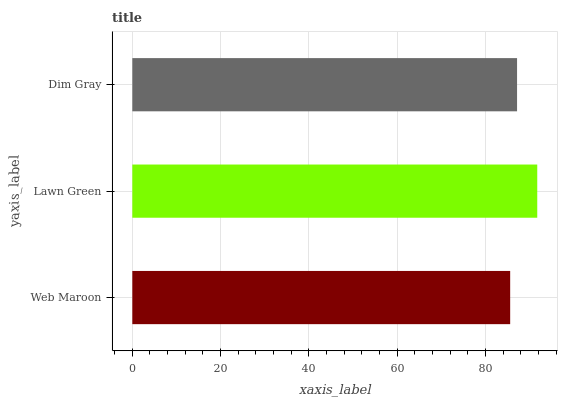Is Web Maroon the minimum?
Answer yes or no. Yes. Is Lawn Green the maximum?
Answer yes or no. Yes. Is Dim Gray the minimum?
Answer yes or no. No. Is Dim Gray the maximum?
Answer yes or no. No. Is Lawn Green greater than Dim Gray?
Answer yes or no. Yes. Is Dim Gray less than Lawn Green?
Answer yes or no. Yes. Is Dim Gray greater than Lawn Green?
Answer yes or no. No. Is Lawn Green less than Dim Gray?
Answer yes or no. No. Is Dim Gray the high median?
Answer yes or no. Yes. Is Dim Gray the low median?
Answer yes or no. Yes. Is Web Maroon the high median?
Answer yes or no. No. Is Web Maroon the low median?
Answer yes or no. No. 